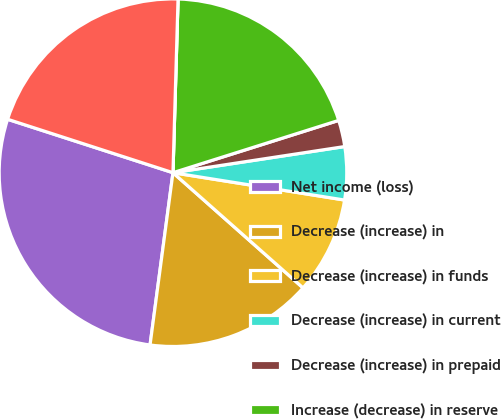Convert chart. <chart><loc_0><loc_0><loc_500><loc_500><pie_chart><fcel>Net income (loss)<fcel>Decrease (increase) in<fcel>Decrease (increase) in funds<fcel>Decrease (increase) in current<fcel>Decrease (increase) in prepaid<fcel>Increase (decrease) in reserve<fcel>Increase (decrease) in future<fcel>Increase (decrease) in losses<nl><fcel>27.87%<fcel>15.57%<fcel>9.02%<fcel>4.92%<fcel>2.46%<fcel>19.67%<fcel>0.0%<fcel>20.49%<nl></chart> 